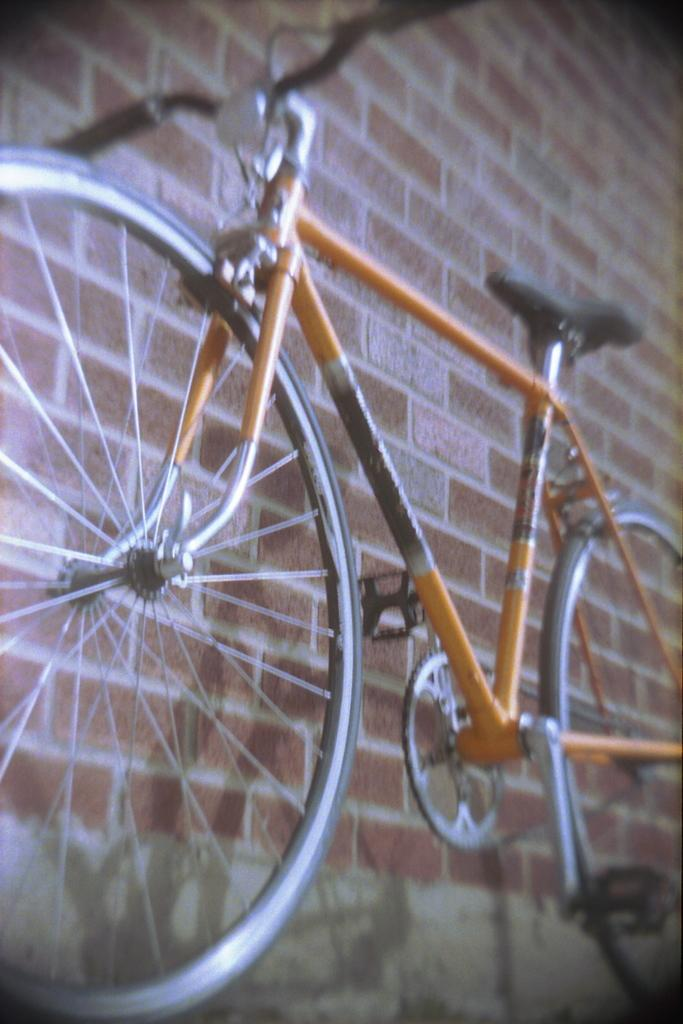What is the main subject of the picture? The main subject of the picture is a bicycle. What can be seen in the background of the picture? There is a wall in the background of the picture. How many ants are crawling on the bicycle in the image? There are no ants visible on the bicycle in the image. What type of calculator is present on the wall in the image? There is no calculator present on the wall in the image. 